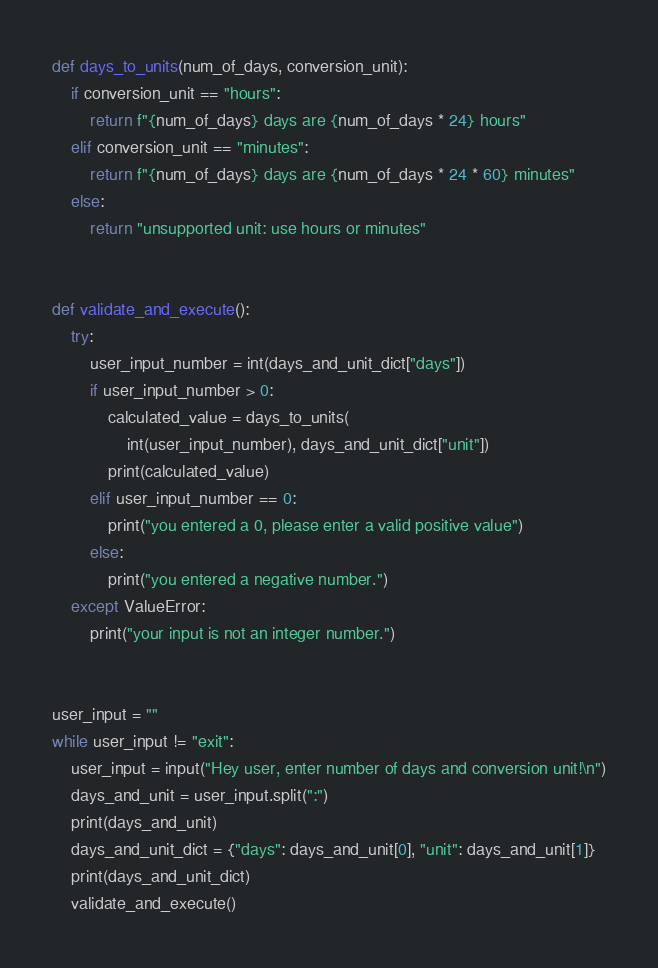<code> <loc_0><loc_0><loc_500><loc_500><_Python_>
def days_to_units(num_of_days, conversion_unit):
    if conversion_unit == "hours":
        return f"{num_of_days} days are {num_of_days * 24} hours"
    elif conversion_unit == "minutes":
        return f"{num_of_days} days are {num_of_days * 24 * 60} minutes"
    else:
        return "unsupported unit: use hours or minutes"


def validate_and_execute():
    try:
        user_input_number = int(days_and_unit_dict["days"])
        if user_input_number > 0:
            calculated_value = days_to_units(
                int(user_input_number), days_and_unit_dict["unit"])
            print(calculated_value)
        elif user_input_number == 0:
            print("you entered a 0, please enter a valid positive value")
        else:
            print("you entered a negative number.")
    except ValueError:
        print("your input is not an integer number.")


user_input = ""
while user_input != "exit":
    user_input = input("Hey user, enter number of days and conversion unit!\n")
    days_and_unit = user_input.split(":")
    print(days_and_unit)
    days_and_unit_dict = {"days": days_and_unit[0], "unit": days_and_unit[1]}
    print(days_and_unit_dict)
    validate_and_execute()
</code> 